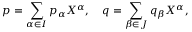Convert formula to latex. <formula><loc_0><loc_0><loc_500><loc_500>p = \sum _ { \alpha \in I } p _ { \alpha } X ^ { \alpha } , \quad q = \sum _ { \beta \in J } q _ { \beta } X ^ { \alpha } ,</formula> 